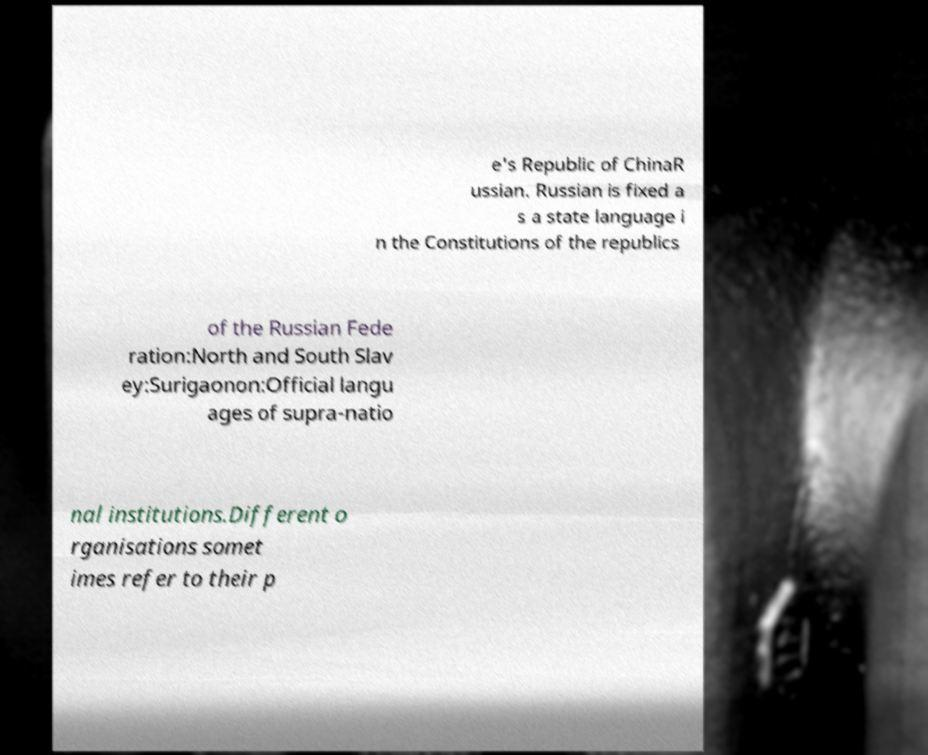For documentation purposes, I need the text within this image transcribed. Could you provide that? e's Republic of ChinaR ussian. Russian is fixed a s a state language i n the Constitutions of the republics of the Russian Fede ration:North and South Slav ey:Surigaonon:Official langu ages of supra-natio nal institutions.Different o rganisations somet imes refer to their p 